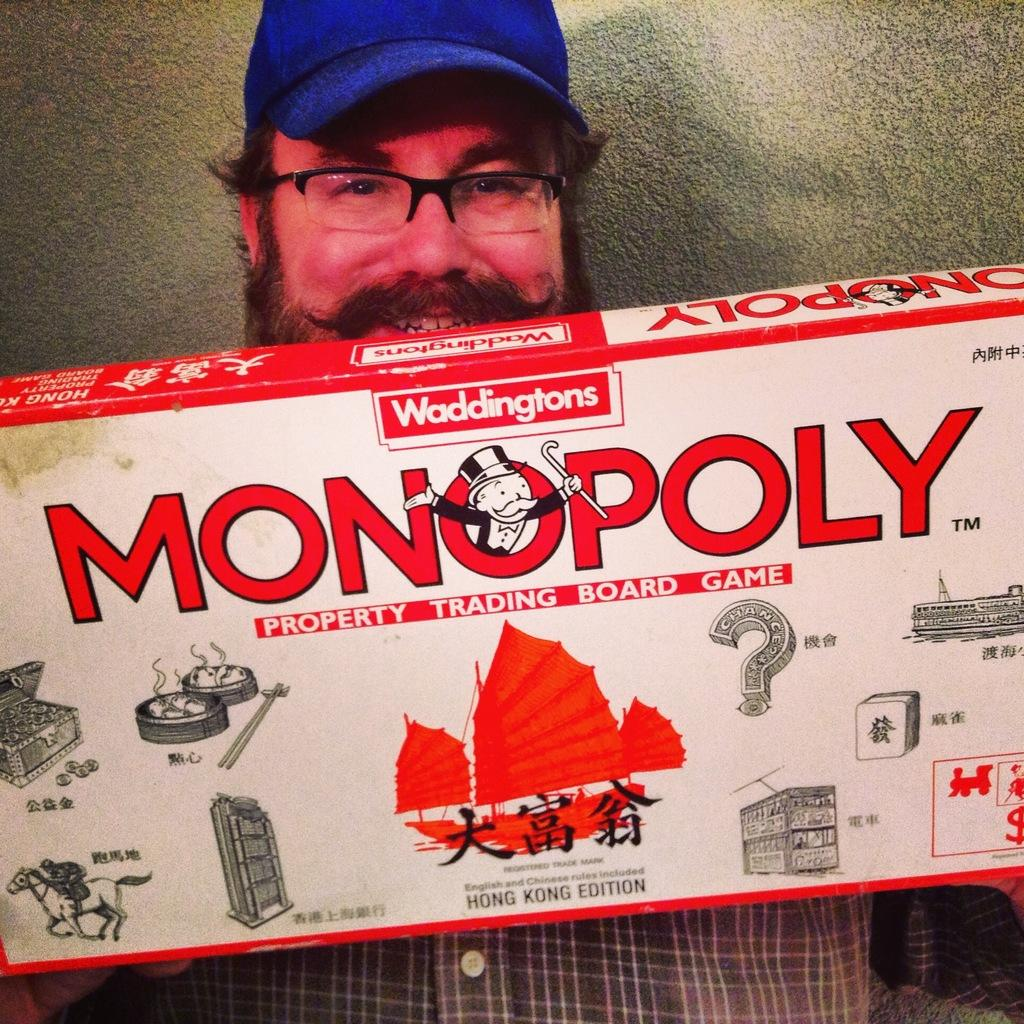What is the main subject of the image? There is a person standing in the image. What is the person holding in the image? The person is holding an object. What can be seen in the background of the image? There is a wall in the background of the image. How many kittens are sitting on the wall in the image? There are no kittens present in the image; only a person and a wall are visible. What type of birds can be seen flying in the background of the image? There are no birds visible in the image; only a person, an object, and a wall are present. 